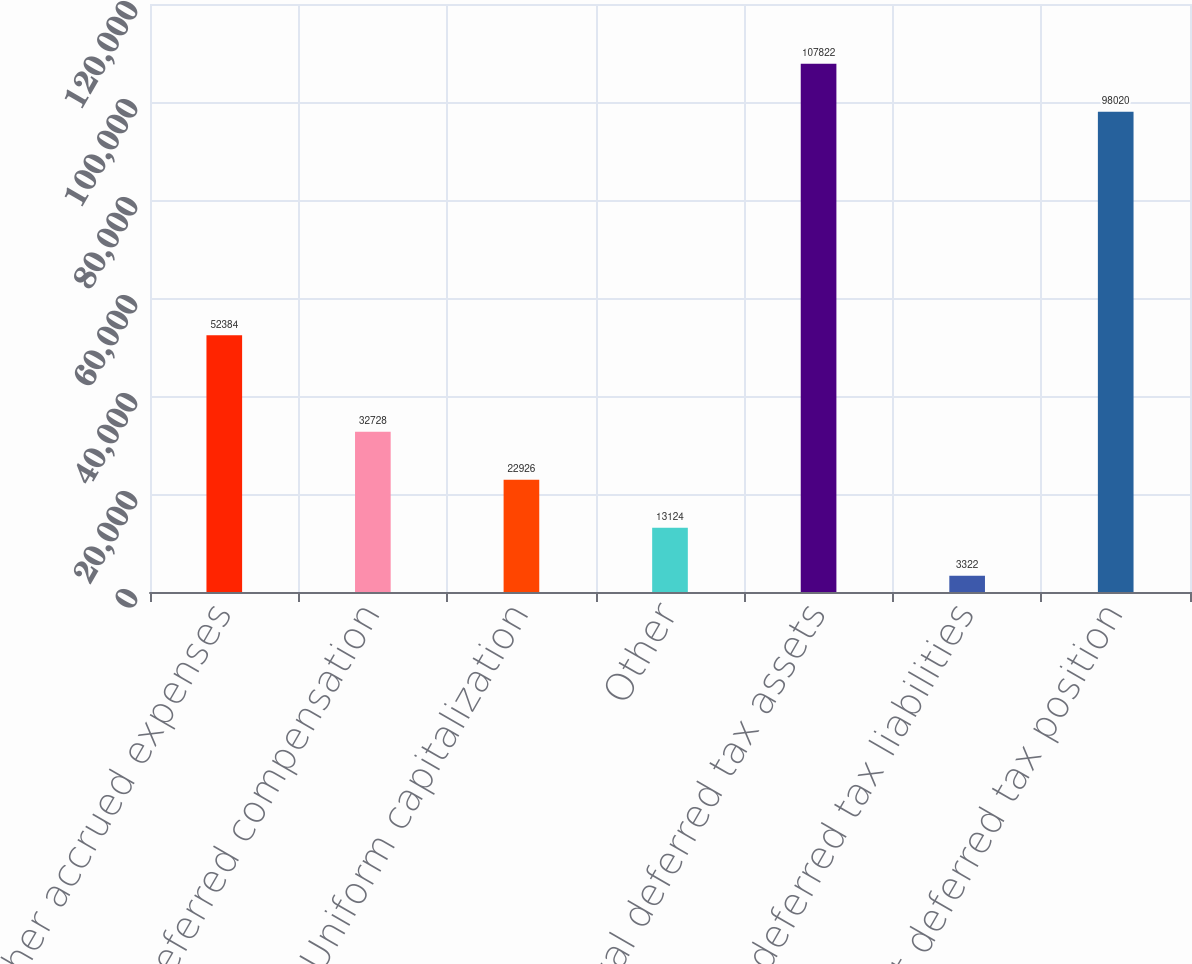Convert chart. <chart><loc_0><loc_0><loc_500><loc_500><bar_chart><fcel>Other accrued expenses<fcel>Deferred compensation<fcel>Uniform capitalization<fcel>Other<fcel>Total deferred tax assets<fcel>Less deferred tax liabilities<fcel>Net deferred tax position<nl><fcel>52384<fcel>32728<fcel>22926<fcel>13124<fcel>107822<fcel>3322<fcel>98020<nl></chart> 